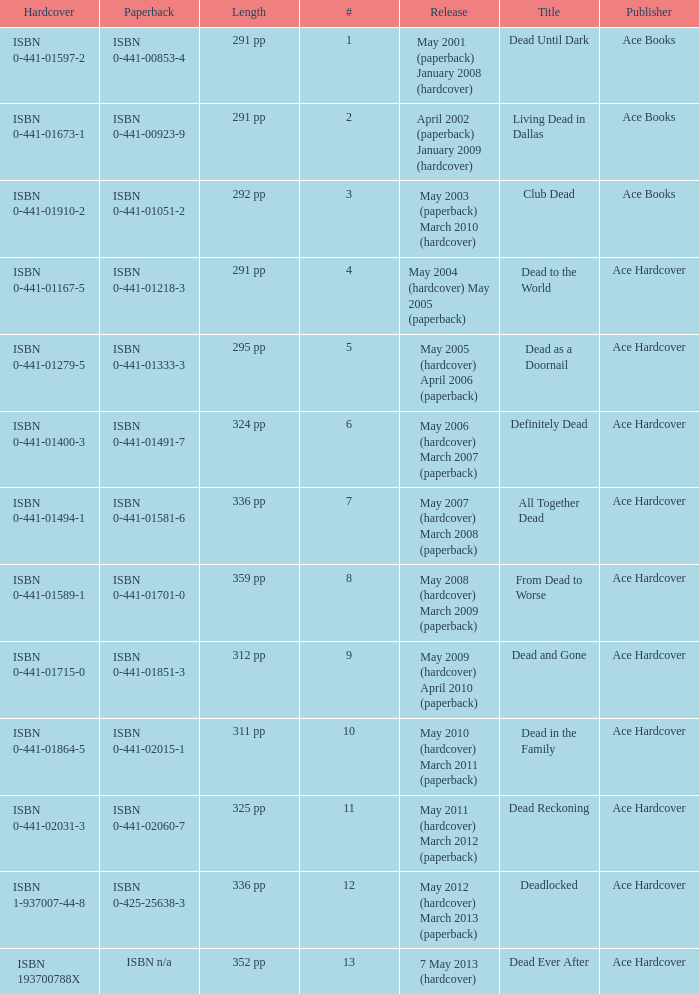Help me parse the entirety of this table. {'header': ['Hardcover', 'Paperback', 'Length', '#', 'Release', 'Title', 'Publisher'], 'rows': [['ISBN 0-441-01597-2', 'ISBN 0-441-00853-4', '291 pp', '1', 'May 2001 (paperback) January 2008 (hardcover)', 'Dead Until Dark', 'Ace Books'], ['ISBN 0-441-01673-1', 'ISBN 0-441-00923-9', '291 pp', '2', 'April 2002 (paperback) January 2009 (hardcover)', 'Living Dead in Dallas', 'Ace Books'], ['ISBN 0-441-01910-2', 'ISBN 0-441-01051-2', '292 pp', '3', 'May 2003 (paperback) March 2010 (hardcover)', 'Club Dead', 'Ace Books'], ['ISBN 0-441-01167-5', 'ISBN 0-441-01218-3', '291 pp', '4', 'May 2004 (hardcover) May 2005 (paperback)', 'Dead to the World', 'Ace Hardcover'], ['ISBN 0-441-01279-5', 'ISBN 0-441-01333-3', '295 pp', '5', 'May 2005 (hardcover) April 2006 (paperback)', 'Dead as a Doornail', 'Ace Hardcover'], ['ISBN 0-441-01400-3', 'ISBN 0-441-01491-7', '324 pp', '6', 'May 2006 (hardcover) March 2007 (paperback)', 'Definitely Dead', 'Ace Hardcover'], ['ISBN 0-441-01494-1', 'ISBN 0-441-01581-6', '336 pp', '7', 'May 2007 (hardcover) March 2008 (paperback)', 'All Together Dead', 'Ace Hardcover'], ['ISBN 0-441-01589-1', 'ISBN 0-441-01701-0', '359 pp', '8', 'May 2008 (hardcover) March 2009 (paperback)', 'From Dead to Worse', 'Ace Hardcover'], ['ISBN 0-441-01715-0', 'ISBN 0-441-01851-3', '312 pp', '9', 'May 2009 (hardcover) April 2010 (paperback)', 'Dead and Gone', 'Ace Hardcover'], ['ISBN 0-441-01864-5', 'ISBN 0-441-02015-1', '311 pp', '10', 'May 2010 (hardcover) March 2011 (paperback)', 'Dead in the Family', 'Ace Hardcover'], ['ISBN 0-441-02031-3', 'ISBN 0-441-02060-7', '325 pp', '11', 'May 2011 (hardcover) March 2012 (paperback)', 'Dead Reckoning', 'Ace Hardcover'], ['ISBN 1-937007-44-8', 'ISBN 0-425-25638-3', '336 pp', '12', 'May 2012 (hardcover) March 2013 (paperback)', 'Deadlocked', 'Ace Hardcover'], ['ISBN 193700788X', 'ISBN n/a', '352 pp', '13', '7 May 2013 (hardcover)', 'Dead Ever After', 'Ace Hardcover']]} What is the ISBN of "Dead as a Doornail? ISBN 0-441-01333-3. 